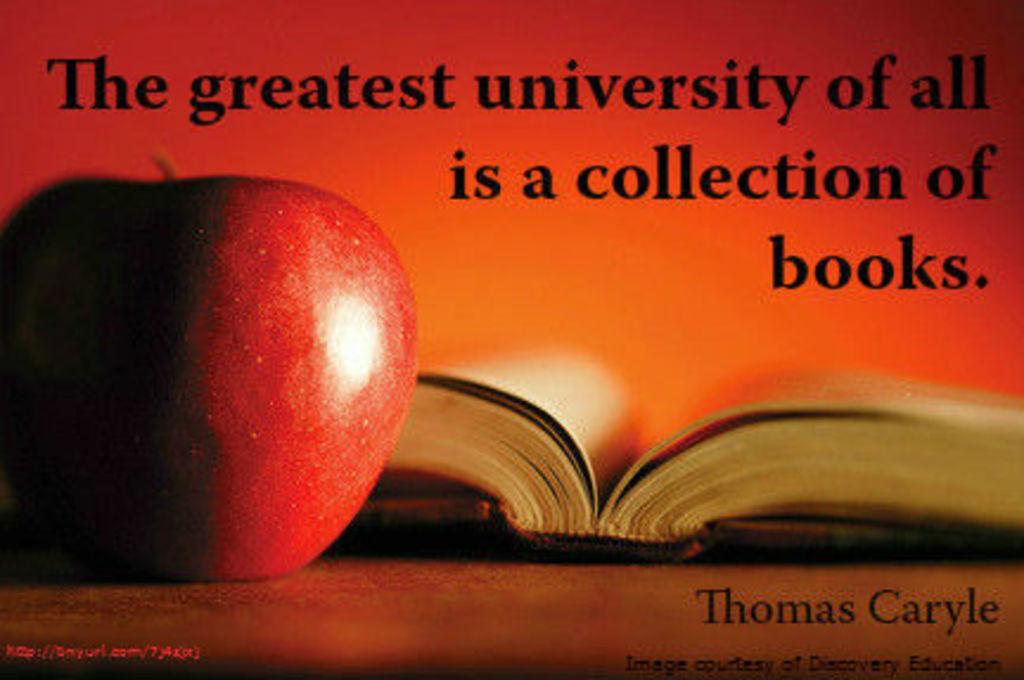What did thomas caryle say?
Your response must be concise. The greatest university of all is a collection of books. 